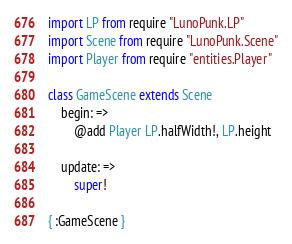Convert code to text. <code><loc_0><loc_0><loc_500><loc_500><_MoonScript_>import LP from require "LunoPunk.LP"
import Scene from require "LunoPunk.Scene"
import Player from require "entities.Player"

class GameScene extends Scene
	begin: =>
		@add Player LP.halfWidth!, LP.height

	update: =>
		super!

{ :GameScene }
</code> 